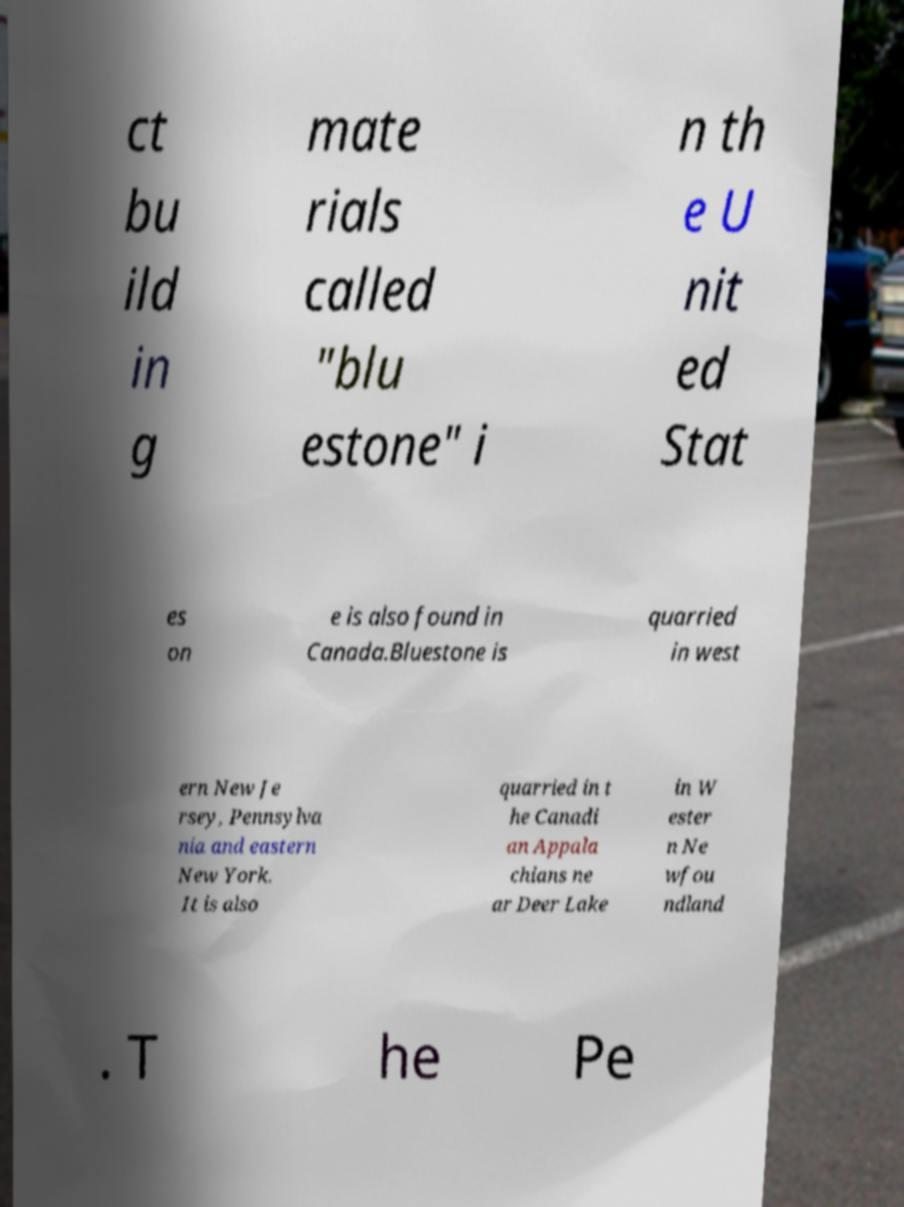Please identify and transcribe the text found in this image. ct bu ild in g mate rials called "blu estone" i n th e U nit ed Stat es on e is also found in Canada.Bluestone is quarried in west ern New Je rsey, Pennsylva nia and eastern New York. It is also quarried in t he Canadi an Appala chians ne ar Deer Lake in W ester n Ne wfou ndland . T he Pe 